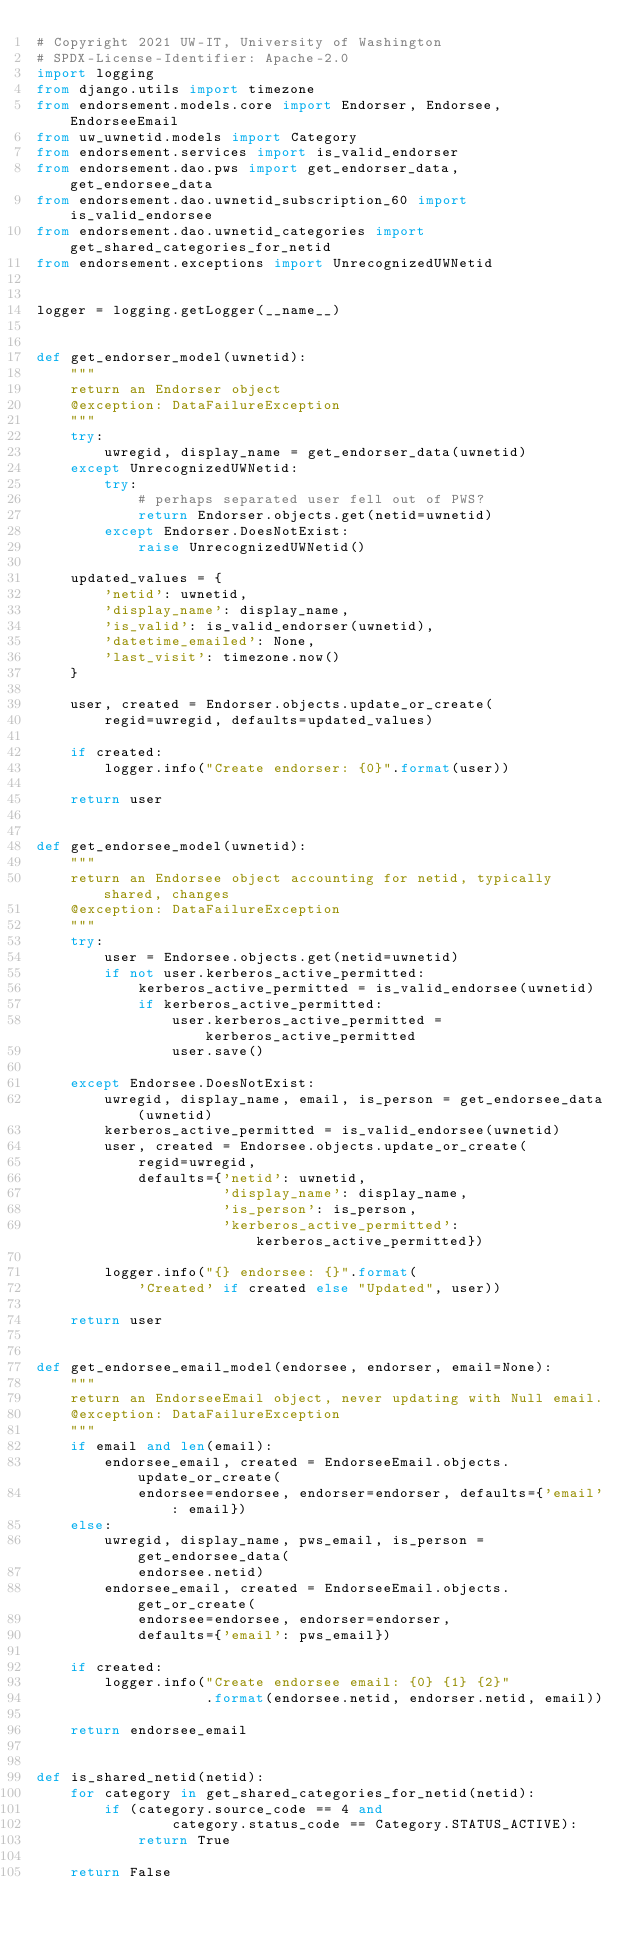Convert code to text. <code><loc_0><loc_0><loc_500><loc_500><_Python_># Copyright 2021 UW-IT, University of Washington
# SPDX-License-Identifier: Apache-2.0
import logging
from django.utils import timezone
from endorsement.models.core import Endorser, Endorsee, EndorseeEmail
from uw_uwnetid.models import Category
from endorsement.services import is_valid_endorser
from endorsement.dao.pws import get_endorser_data, get_endorsee_data
from endorsement.dao.uwnetid_subscription_60 import is_valid_endorsee
from endorsement.dao.uwnetid_categories import get_shared_categories_for_netid
from endorsement.exceptions import UnrecognizedUWNetid


logger = logging.getLogger(__name__)


def get_endorser_model(uwnetid):
    """
    return an Endorser object
    @exception: DataFailureException
    """
    try:
        uwregid, display_name = get_endorser_data(uwnetid)
    except UnrecognizedUWNetid:
        try:
            # perhaps separated user fell out of PWS?
            return Endorser.objects.get(netid=uwnetid)
        except Endorser.DoesNotExist:
            raise UnrecognizedUWNetid()

    updated_values = {
        'netid': uwnetid,
        'display_name': display_name,
        'is_valid': is_valid_endorser(uwnetid),
        'datetime_emailed': None,
        'last_visit': timezone.now()
    }

    user, created = Endorser.objects.update_or_create(
        regid=uwregid, defaults=updated_values)

    if created:
        logger.info("Create endorser: {0}".format(user))

    return user


def get_endorsee_model(uwnetid):
    """
    return an Endorsee object accounting for netid, typically shared, changes
    @exception: DataFailureException
    """
    try:
        user = Endorsee.objects.get(netid=uwnetid)
        if not user.kerberos_active_permitted:
            kerberos_active_permitted = is_valid_endorsee(uwnetid)
            if kerberos_active_permitted:
                user.kerberos_active_permitted = kerberos_active_permitted
                user.save()

    except Endorsee.DoesNotExist:
        uwregid, display_name, email, is_person = get_endorsee_data(uwnetid)
        kerberos_active_permitted = is_valid_endorsee(uwnetid)
        user, created = Endorsee.objects.update_or_create(
            regid=uwregid,
            defaults={'netid': uwnetid,
                      'display_name': display_name,
                      'is_person': is_person,
                      'kerberos_active_permitted': kerberos_active_permitted})

        logger.info("{} endorsee: {}".format(
            'Created' if created else "Updated", user))

    return user


def get_endorsee_email_model(endorsee, endorser, email=None):
    """
    return an EndorseeEmail object, never updating with Null email.
    @exception: DataFailureException
    """
    if email and len(email):
        endorsee_email, created = EndorseeEmail.objects.update_or_create(
            endorsee=endorsee, endorser=endorser, defaults={'email': email})
    else:
        uwregid, display_name, pws_email, is_person = get_endorsee_data(
            endorsee.netid)
        endorsee_email, created = EndorseeEmail.objects.get_or_create(
            endorsee=endorsee, endorser=endorser,
            defaults={'email': pws_email})

    if created:
        logger.info("Create endorsee email: {0} {1} {2}"
                    .format(endorsee.netid, endorser.netid, email))

    return endorsee_email


def is_shared_netid(netid):
    for category in get_shared_categories_for_netid(netid):
        if (category.source_code == 4 and
                category.status_code == Category.STATUS_ACTIVE):
            return True

    return False
</code> 